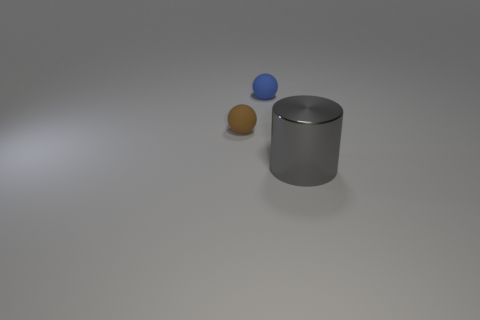What number of other things are there of the same color as the large metal thing?
Make the answer very short. 0. What is the material of the ball behind the small rubber object in front of the blue rubber sphere?
Your response must be concise. Rubber. Are any small brown spheres visible?
Keep it short and to the point. Yes. There is a rubber object behind the tiny rubber ball that is in front of the tiny blue rubber object; what is its size?
Keep it short and to the point. Small. Is the number of shiny things to the left of the blue object greater than the number of gray cylinders that are on the left side of the small brown thing?
Provide a short and direct response. No. What number of balls are blue rubber things or big gray objects?
Offer a very short reply. 1. Are there any other things that have the same size as the shiny thing?
Keep it short and to the point. No. There is a small thing that is behind the tiny brown matte ball; is its shape the same as the large thing?
Ensure brevity in your answer.  No. The large metallic thing is what color?
Your response must be concise. Gray. What color is the other object that is the same shape as the blue object?
Ensure brevity in your answer.  Brown. 